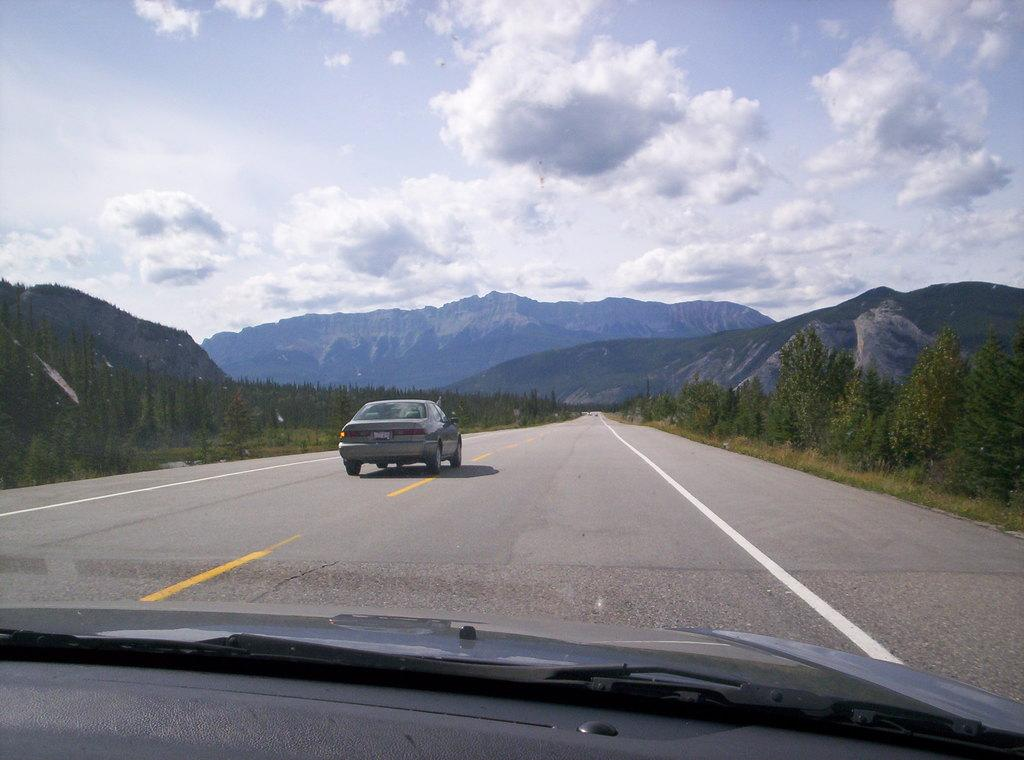What is the main feature of the image? There is a road in the image. What is on the road? There is a car on the road. How much of the car can be seen in the image? The front of the car is visible at the bottom of the image. What type of vegetation is present near the road? There are trees on the sides of the road. What can be seen in the distance behind the trees? There are hills in the background of the image. What is visible in the sky? The sky is visible in the background of the image, and clouds are present. Can you tell me how many bags of popcorn are on the side of the road? There are no bags of popcorn present in the image; it features a road, a car, trees, hills, and a sky with clouds. 